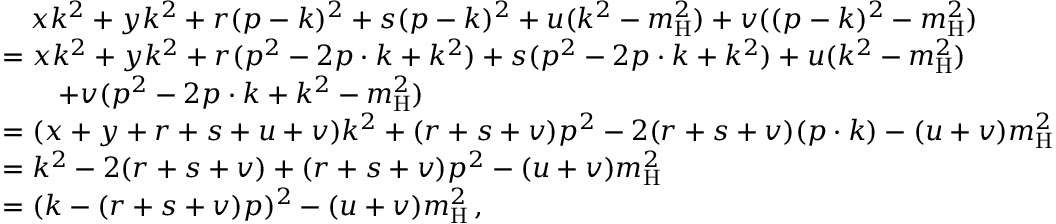Convert formula to latex. <formula><loc_0><loc_0><loc_500><loc_500>\begin{array} { r l } & { \quad x k ^ { 2 } + y k ^ { 2 } + r ( p - k ) ^ { 2 } + s ( p - k ) ^ { 2 } + u ( k ^ { 2 } - m _ { H } ^ { 2 } ) + v ( ( p - k ) ^ { 2 } - m _ { H } ^ { 2 } ) } \\ & { = x k ^ { 2 } + y k ^ { 2 } + r ( p ^ { 2 } - 2 p \cdot k + k ^ { 2 } ) + s ( p ^ { 2 } - 2 p \cdot k + k ^ { 2 } ) + u ( k ^ { 2 } - m _ { H } ^ { 2 } ) } \\ & { \quad + v ( p ^ { 2 } - 2 p \cdot k + k ^ { 2 } - m _ { H } ^ { 2 } ) } \\ & { = ( x + y + r + s + u + v ) k ^ { 2 } + ( r + s + v ) p ^ { 2 } - 2 ( r + s + v ) ( p \cdot k ) - ( u + v ) m _ { H } ^ { 2 } } \\ & { = k ^ { 2 } - 2 ( r + s + v ) + ( r + s + v ) p ^ { 2 } - ( u + v ) m _ { H } ^ { 2 } } \\ & { = ( k - ( r + s + v ) p ) ^ { 2 } - ( u + v ) m _ { H } ^ { 2 } \, , } \end{array}</formula> 